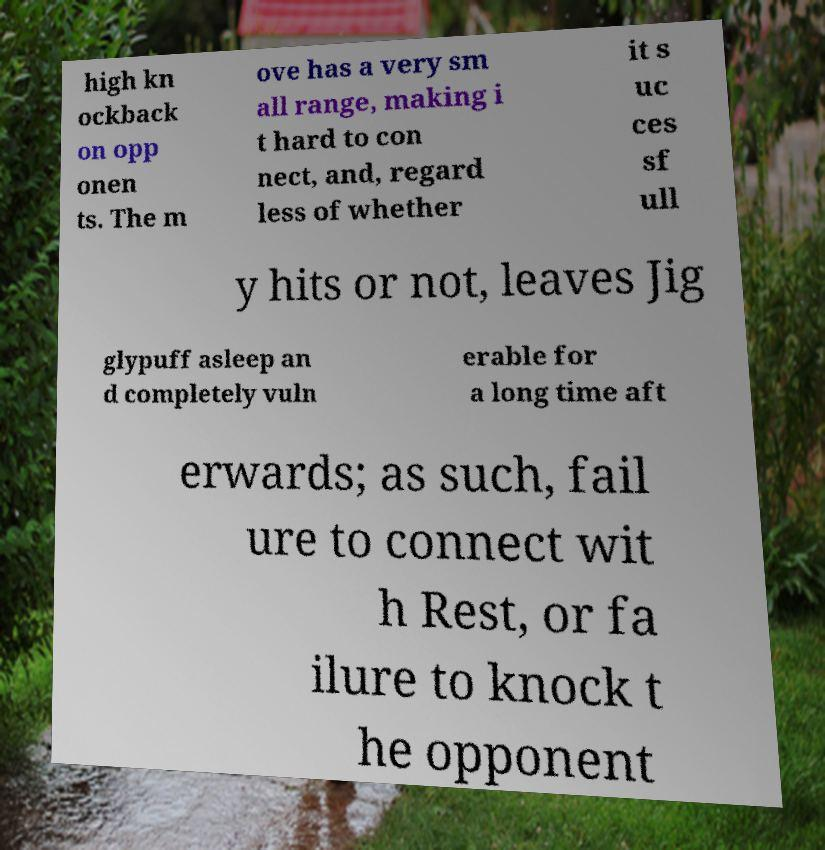There's text embedded in this image that I need extracted. Can you transcribe it verbatim? high kn ockback on opp onen ts. The m ove has a very sm all range, making i t hard to con nect, and, regard less of whether it s uc ces sf ull y hits or not, leaves Jig glypuff asleep an d completely vuln erable for a long time aft erwards; as such, fail ure to connect wit h Rest, or fa ilure to knock t he opponent 